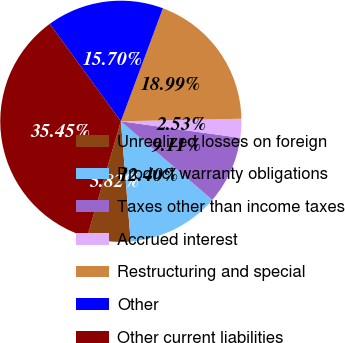Convert chart. <chart><loc_0><loc_0><loc_500><loc_500><pie_chart><fcel>Unrealized losses on foreign<fcel>Product warranty obligations<fcel>Taxes other than income taxes<fcel>Accrued interest<fcel>Restructuring and special<fcel>Other<fcel>Other current liabilities<nl><fcel>5.82%<fcel>12.4%<fcel>9.11%<fcel>2.53%<fcel>18.99%<fcel>15.7%<fcel>35.45%<nl></chart> 